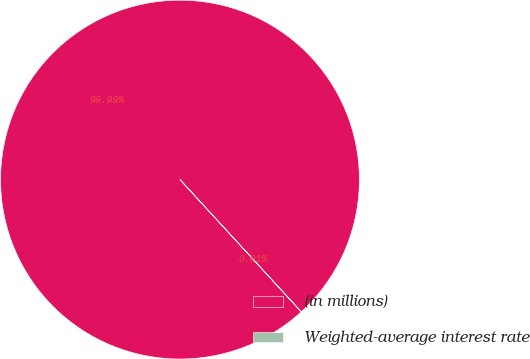<chart> <loc_0><loc_0><loc_500><loc_500><pie_chart><fcel>(in millions)<fcel>Weighted-average interest rate<nl><fcel>99.99%<fcel>0.01%<nl></chart> 